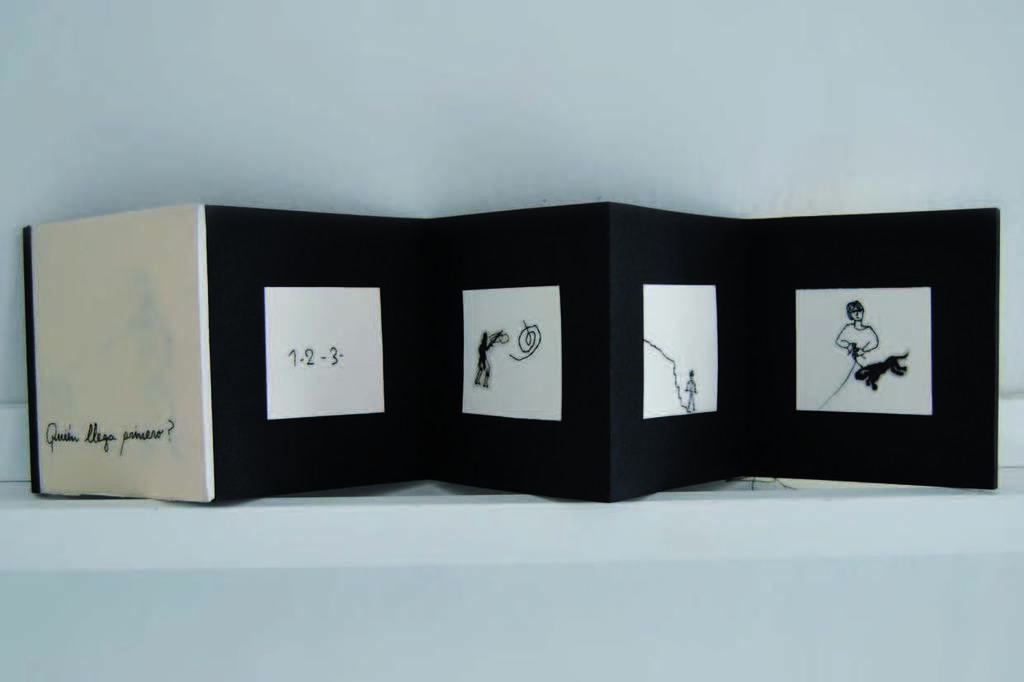What is the main object in the image? There is a board in the image. What color is the board? The board is in black and white color. What can be seen in the background of the image? There is a white wall in the background of the image. What type of cabbage is growing on the street in the image? There is no cabbage or street present in the image; it only features a board and a white wall in the background. 